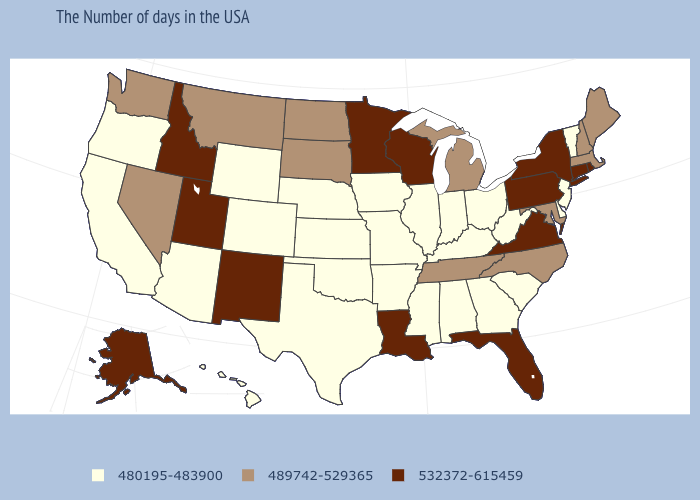Does the map have missing data?
Be succinct. No. What is the value of North Dakota?
Give a very brief answer. 489742-529365. Among the states that border Utah , which have the highest value?
Keep it brief. New Mexico, Idaho. Which states have the lowest value in the West?
Quick response, please. Wyoming, Colorado, Arizona, California, Oregon, Hawaii. What is the highest value in the MidWest ?
Quick response, please. 532372-615459. What is the lowest value in the USA?
Give a very brief answer. 480195-483900. What is the highest value in the USA?
Write a very short answer. 532372-615459. Does West Virginia have the same value as Indiana?
Answer briefly. Yes. What is the value of Connecticut?
Quick response, please. 532372-615459. Does New Jersey have the lowest value in the USA?
Give a very brief answer. Yes. Name the states that have a value in the range 489742-529365?
Give a very brief answer. Maine, Massachusetts, New Hampshire, Maryland, North Carolina, Michigan, Tennessee, South Dakota, North Dakota, Montana, Nevada, Washington. Name the states that have a value in the range 532372-615459?
Concise answer only. Rhode Island, Connecticut, New York, Pennsylvania, Virginia, Florida, Wisconsin, Louisiana, Minnesota, New Mexico, Utah, Idaho, Alaska. What is the value of Arkansas?
Answer briefly. 480195-483900. What is the value of New York?
Keep it brief. 532372-615459. Among the states that border Maryland , which have the lowest value?
Concise answer only. Delaware, West Virginia. 